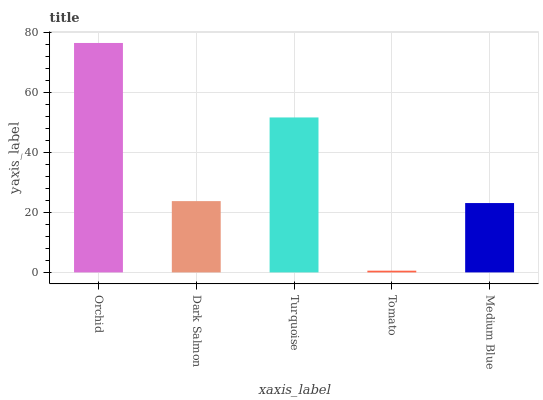Is Tomato the minimum?
Answer yes or no. Yes. Is Orchid the maximum?
Answer yes or no. Yes. Is Dark Salmon the minimum?
Answer yes or no. No. Is Dark Salmon the maximum?
Answer yes or no. No. Is Orchid greater than Dark Salmon?
Answer yes or no. Yes. Is Dark Salmon less than Orchid?
Answer yes or no. Yes. Is Dark Salmon greater than Orchid?
Answer yes or no. No. Is Orchid less than Dark Salmon?
Answer yes or no. No. Is Dark Salmon the high median?
Answer yes or no. Yes. Is Dark Salmon the low median?
Answer yes or no. Yes. Is Orchid the high median?
Answer yes or no. No. Is Medium Blue the low median?
Answer yes or no. No. 